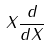Convert formula to latex. <formula><loc_0><loc_0><loc_500><loc_500>X { \frac { d } { d X } }</formula> 